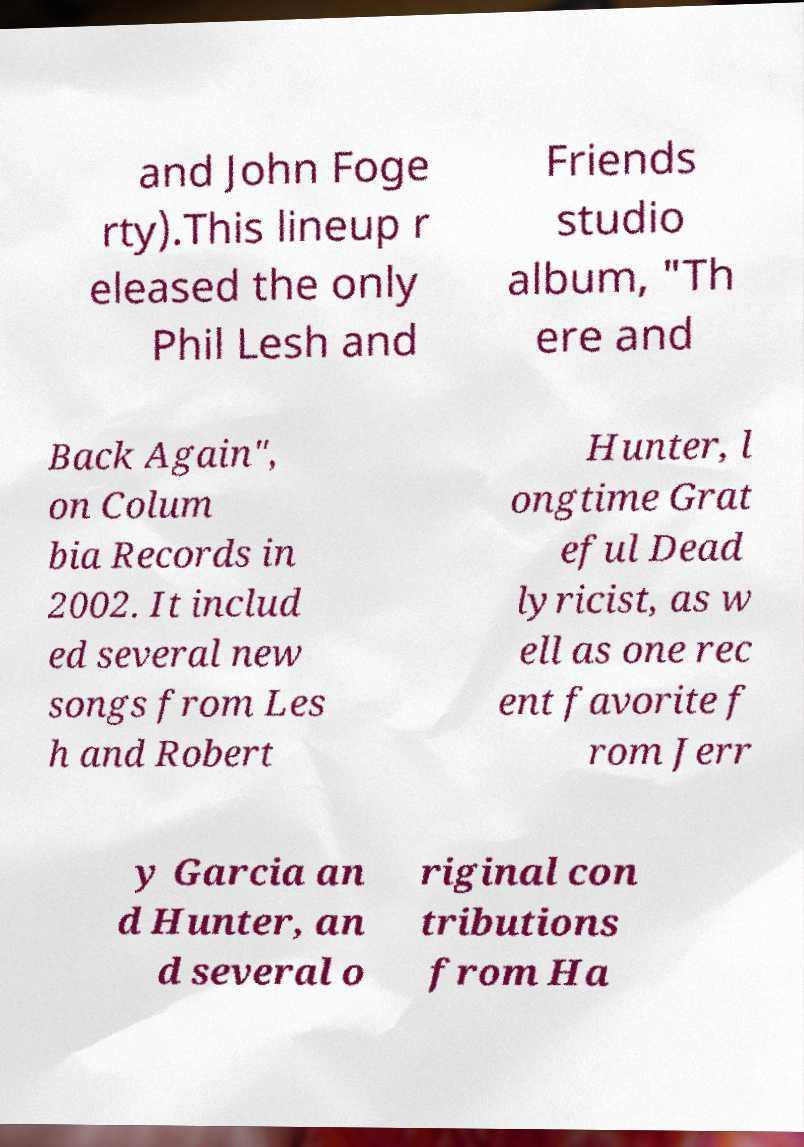Please read and relay the text visible in this image. What does it say? and John Foge rty).This lineup r eleased the only Phil Lesh and Friends studio album, "Th ere and Back Again", on Colum bia Records in 2002. It includ ed several new songs from Les h and Robert Hunter, l ongtime Grat eful Dead lyricist, as w ell as one rec ent favorite f rom Jerr y Garcia an d Hunter, an d several o riginal con tributions from Ha 